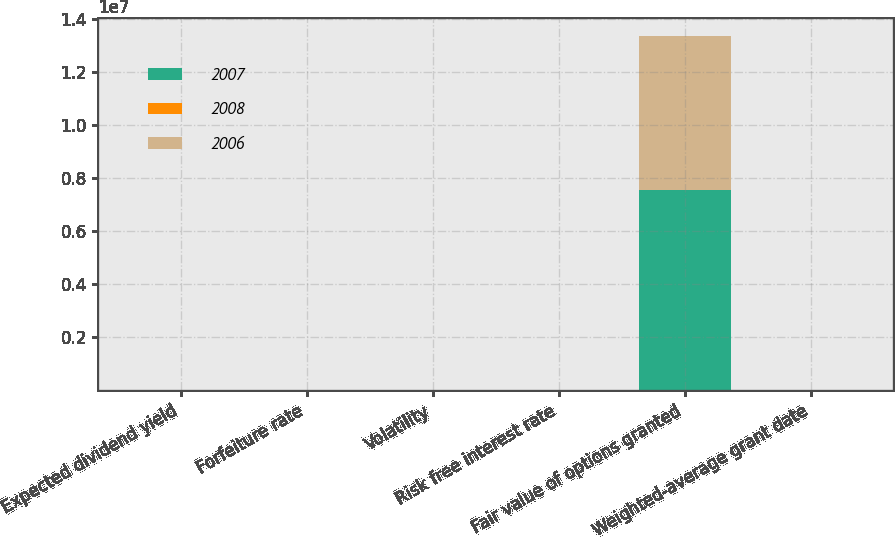<chart> <loc_0><loc_0><loc_500><loc_500><stacked_bar_chart><ecel><fcel>Expected dividend yield<fcel>Forfeiture rate<fcel>Volatility<fcel>Risk free interest rate<fcel>Fair value of options granted<fcel>Weighted-average grant date<nl><fcel>2007<fcel>0<fcel>8.99<fcel>37.79<fcel>3.17<fcel>7.566e+06<fcel>13.33<nl><fcel>2008<fcel>0<fcel>7.69<fcel>34.73<fcel>4.55<fcel>8.99<fcel>13.72<nl><fcel>2006<fcel>0<fcel>7.43<fcel>38.3<fcel>4.58<fcel>5.802e+06<fcel>14.22<nl></chart> 